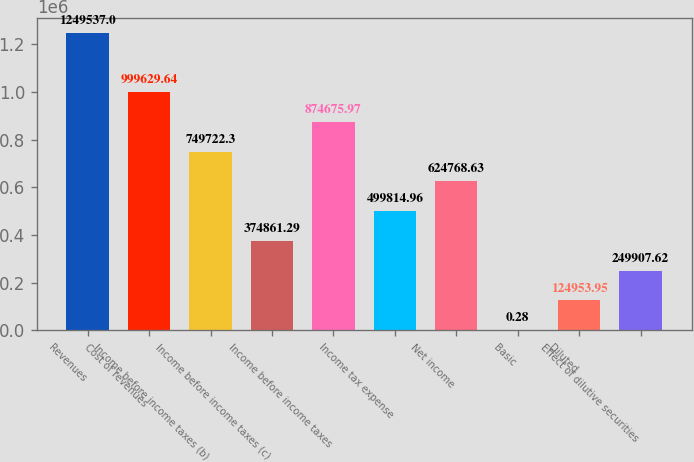Convert chart. <chart><loc_0><loc_0><loc_500><loc_500><bar_chart><fcel>Revenues<fcel>Cost of revenues<fcel>Income before income taxes (b)<fcel>Income before income taxes (c)<fcel>Income before income taxes<fcel>Income tax expense<fcel>Net income<fcel>Basic<fcel>Diluted<fcel>Effect of dilutive securities<nl><fcel>1.24954e+06<fcel>999630<fcel>749722<fcel>374861<fcel>874676<fcel>499815<fcel>624769<fcel>0.28<fcel>124954<fcel>249908<nl></chart> 